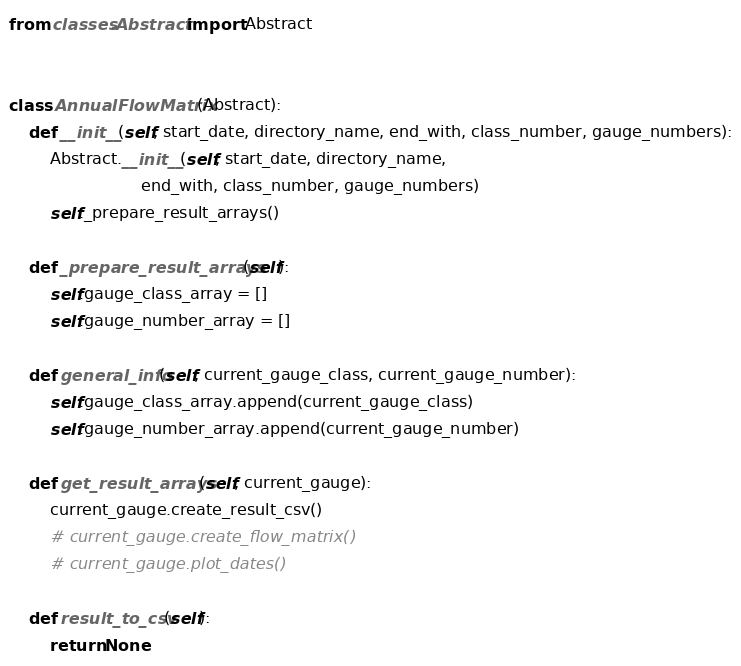<code> <loc_0><loc_0><loc_500><loc_500><_Python_>from classes.Abstract import Abstract


class AnnualFlowMatrix(Abstract):
    def __init__(self, start_date, directory_name, end_with, class_number, gauge_numbers):
        Abstract.__init__(self, start_date, directory_name,
                          end_with, class_number, gauge_numbers)
        self._prepare_result_arrays()

    def _prepare_result_arrays(self):
        self.gauge_class_array = []
        self.gauge_number_array = []

    def general_info(self, current_gauge_class, current_gauge_number):
        self.gauge_class_array.append(current_gauge_class)
        self.gauge_number_array.append(current_gauge_number)

    def get_result_arrays(self, current_gauge):
        current_gauge.create_result_csv()
        # current_gauge.create_flow_matrix()
        # current_gauge.plot_dates()

    def result_to_csv(self):
        return None
</code> 